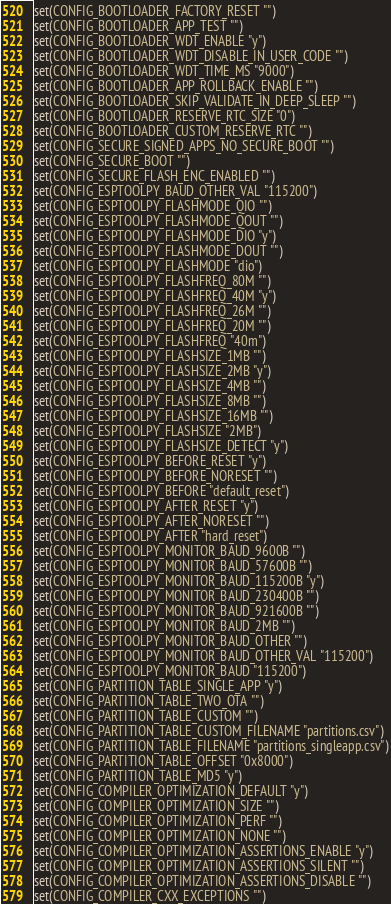Convert code to text. <code><loc_0><loc_0><loc_500><loc_500><_CMake_>set(CONFIG_BOOTLOADER_FACTORY_RESET "")
set(CONFIG_BOOTLOADER_APP_TEST "")
set(CONFIG_BOOTLOADER_WDT_ENABLE "y")
set(CONFIG_BOOTLOADER_WDT_DISABLE_IN_USER_CODE "")
set(CONFIG_BOOTLOADER_WDT_TIME_MS "9000")
set(CONFIG_BOOTLOADER_APP_ROLLBACK_ENABLE "")
set(CONFIG_BOOTLOADER_SKIP_VALIDATE_IN_DEEP_SLEEP "")
set(CONFIG_BOOTLOADER_RESERVE_RTC_SIZE "0")
set(CONFIG_BOOTLOADER_CUSTOM_RESERVE_RTC "")
set(CONFIG_SECURE_SIGNED_APPS_NO_SECURE_BOOT "")
set(CONFIG_SECURE_BOOT "")
set(CONFIG_SECURE_FLASH_ENC_ENABLED "")
set(CONFIG_ESPTOOLPY_BAUD_OTHER_VAL "115200")
set(CONFIG_ESPTOOLPY_FLASHMODE_QIO "")
set(CONFIG_ESPTOOLPY_FLASHMODE_QOUT "")
set(CONFIG_ESPTOOLPY_FLASHMODE_DIO "y")
set(CONFIG_ESPTOOLPY_FLASHMODE_DOUT "")
set(CONFIG_ESPTOOLPY_FLASHMODE "dio")
set(CONFIG_ESPTOOLPY_FLASHFREQ_80M "")
set(CONFIG_ESPTOOLPY_FLASHFREQ_40M "y")
set(CONFIG_ESPTOOLPY_FLASHFREQ_26M "")
set(CONFIG_ESPTOOLPY_FLASHFREQ_20M "")
set(CONFIG_ESPTOOLPY_FLASHFREQ "40m")
set(CONFIG_ESPTOOLPY_FLASHSIZE_1MB "")
set(CONFIG_ESPTOOLPY_FLASHSIZE_2MB "y")
set(CONFIG_ESPTOOLPY_FLASHSIZE_4MB "")
set(CONFIG_ESPTOOLPY_FLASHSIZE_8MB "")
set(CONFIG_ESPTOOLPY_FLASHSIZE_16MB "")
set(CONFIG_ESPTOOLPY_FLASHSIZE "2MB")
set(CONFIG_ESPTOOLPY_FLASHSIZE_DETECT "y")
set(CONFIG_ESPTOOLPY_BEFORE_RESET "y")
set(CONFIG_ESPTOOLPY_BEFORE_NORESET "")
set(CONFIG_ESPTOOLPY_BEFORE "default_reset")
set(CONFIG_ESPTOOLPY_AFTER_RESET "y")
set(CONFIG_ESPTOOLPY_AFTER_NORESET "")
set(CONFIG_ESPTOOLPY_AFTER "hard_reset")
set(CONFIG_ESPTOOLPY_MONITOR_BAUD_9600B "")
set(CONFIG_ESPTOOLPY_MONITOR_BAUD_57600B "")
set(CONFIG_ESPTOOLPY_MONITOR_BAUD_115200B "y")
set(CONFIG_ESPTOOLPY_MONITOR_BAUD_230400B "")
set(CONFIG_ESPTOOLPY_MONITOR_BAUD_921600B "")
set(CONFIG_ESPTOOLPY_MONITOR_BAUD_2MB "")
set(CONFIG_ESPTOOLPY_MONITOR_BAUD_OTHER "")
set(CONFIG_ESPTOOLPY_MONITOR_BAUD_OTHER_VAL "115200")
set(CONFIG_ESPTOOLPY_MONITOR_BAUD "115200")
set(CONFIG_PARTITION_TABLE_SINGLE_APP "y")
set(CONFIG_PARTITION_TABLE_TWO_OTA "")
set(CONFIG_PARTITION_TABLE_CUSTOM "")
set(CONFIG_PARTITION_TABLE_CUSTOM_FILENAME "partitions.csv")
set(CONFIG_PARTITION_TABLE_FILENAME "partitions_singleapp.csv")
set(CONFIG_PARTITION_TABLE_OFFSET "0x8000")
set(CONFIG_PARTITION_TABLE_MD5 "y")
set(CONFIG_COMPILER_OPTIMIZATION_DEFAULT "y")
set(CONFIG_COMPILER_OPTIMIZATION_SIZE "")
set(CONFIG_COMPILER_OPTIMIZATION_PERF "")
set(CONFIG_COMPILER_OPTIMIZATION_NONE "")
set(CONFIG_COMPILER_OPTIMIZATION_ASSERTIONS_ENABLE "y")
set(CONFIG_COMPILER_OPTIMIZATION_ASSERTIONS_SILENT "")
set(CONFIG_COMPILER_OPTIMIZATION_ASSERTIONS_DISABLE "")
set(CONFIG_COMPILER_CXX_EXCEPTIONS "")</code> 